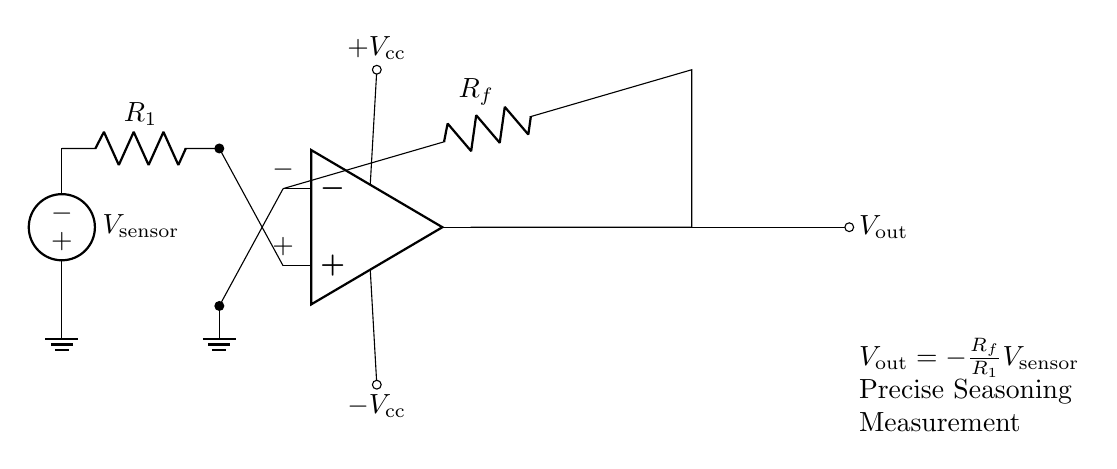What type of circuit is this? This is an operational amplifier circuit, which is commonly used for amplifying voltage signals. The key component here is the op-amp.
Answer: Operational amplifier What does the output voltage represent? The output voltage is defined by the formula V out = -R f / R 1 * V sensor. This means it represents the amplified version of the input voltage from the seasoning sensor.
Answer: Amplified voltage What are the two resistors in this circuit? The two resistors present in the circuit are R1 and Rf. R1 is the input resistor connected to the sensor, while Rf is the feedback resistor connected from the output back to the inverting input of the op-amp.
Answer: R1 and Rf What is the function of the feedback resistor Rf? The feedback resistor Rf control the gain of the operational amplifier by determining the ratio of the output voltage to the input voltage. It helps to stabilize the output based on the input.
Answer: Control gain How does the voltage at the non-inverting terminal relate to the circuit operation? The voltage at the non-inverting terminal (+) is at the voltage level of the seasoning sensor (V sensor). It sets the reference voltage that helps the op-amp produce the desired output based on the input signal.
Answer: Reference voltage What is the polarity of the V out in this circuit? The output voltage (V out) is represented as negative in the formula, indicating that the op-amp inverts the input signal. Therefore, the output signal is inverted compared to the input.
Answer: Negative polarity 